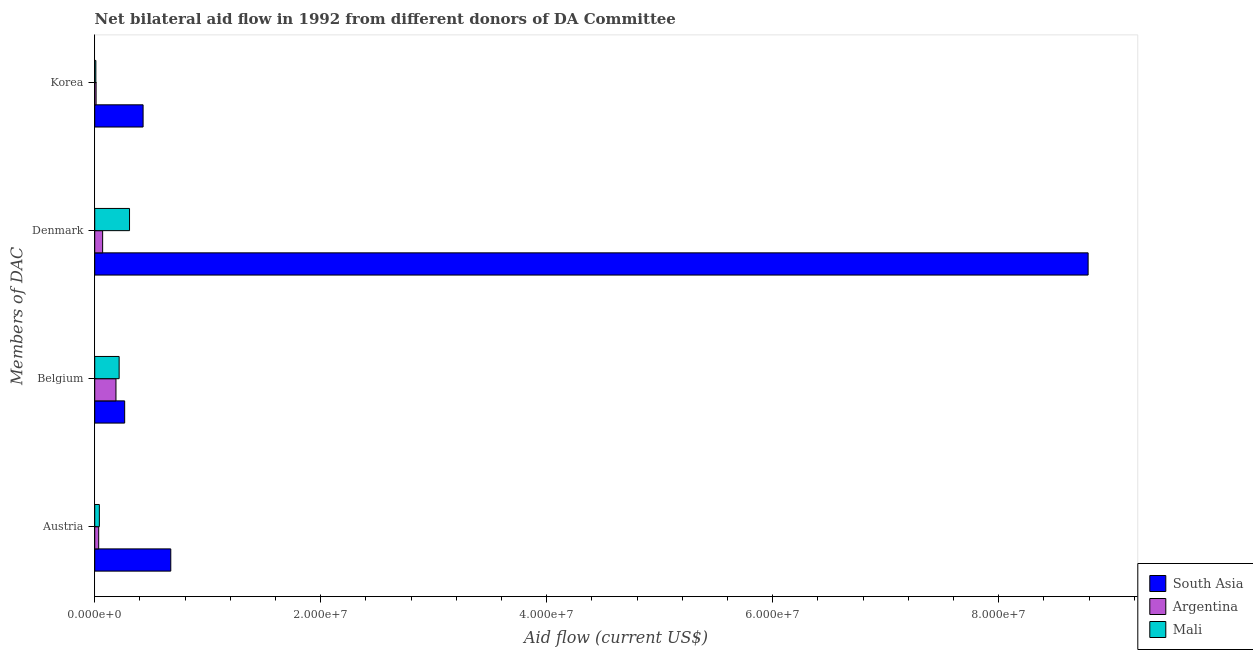How many different coloured bars are there?
Your answer should be compact. 3. Are the number of bars on each tick of the Y-axis equal?
Provide a succinct answer. Yes. How many bars are there on the 3rd tick from the bottom?
Your answer should be compact. 3. What is the amount of aid given by denmark in Argentina?
Your answer should be compact. 7.00e+05. Across all countries, what is the maximum amount of aid given by denmark?
Your response must be concise. 8.79e+07. Across all countries, what is the minimum amount of aid given by austria?
Ensure brevity in your answer.  3.50e+05. In which country was the amount of aid given by korea minimum?
Make the answer very short. Mali. What is the total amount of aid given by belgium in the graph?
Provide a succinct answer. 6.69e+06. What is the difference between the amount of aid given by austria in Argentina and that in South Asia?
Offer a very short reply. -6.38e+06. What is the difference between the amount of aid given by denmark in Mali and the amount of aid given by belgium in Argentina?
Provide a short and direct response. 1.20e+06. What is the average amount of aid given by korea per country?
Make the answer very short. 1.50e+06. What is the difference between the amount of aid given by korea and amount of aid given by denmark in Argentina?
Ensure brevity in your answer.  -5.80e+05. What is the ratio of the amount of aid given by belgium in Argentina to that in South Asia?
Make the answer very short. 0.71. Is the amount of aid given by korea in Mali less than that in Argentina?
Offer a very short reply. Yes. What is the difference between the highest and the second highest amount of aid given by belgium?
Provide a succinct answer. 4.90e+05. What is the difference between the highest and the lowest amount of aid given by austria?
Your answer should be very brief. 6.38e+06. Is the sum of the amount of aid given by austria in Mali and Argentina greater than the maximum amount of aid given by belgium across all countries?
Offer a terse response. No. Is it the case that in every country, the sum of the amount of aid given by korea and amount of aid given by austria is greater than the sum of amount of aid given by belgium and amount of aid given by denmark?
Your answer should be very brief. No. What does the 2nd bar from the top in Denmark represents?
Give a very brief answer. Argentina. What does the 1st bar from the bottom in Austria represents?
Give a very brief answer. South Asia. How many bars are there?
Offer a terse response. 12. Are all the bars in the graph horizontal?
Make the answer very short. Yes. How many countries are there in the graph?
Provide a short and direct response. 3. Does the graph contain any zero values?
Keep it short and to the point. No. How many legend labels are there?
Your answer should be compact. 3. How are the legend labels stacked?
Your response must be concise. Vertical. What is the title of the graph?
Your response must be concise. Net bilateral aid flow in 1992 from different donors of DA Committee. Does "Honduras" appear as one of the legend labels in the graph?
Provide a short and direct response. No. What is the label or title of the Y-axis?
Your answer should be compact. Members of DAC. What is the Aid flow (current US$) in South Asia in Austria?
Offer a terse response. 6.73e+06. What is the Aid flow (current US$) in Argentina in Austria?
Offer a very short reply. 3.50e+05. What is the Aid flow (current US$) in Mali in Austria?
Keep it short and to the point. 4.10e+05. What is the Aid flow (current US$) in South Asia in Belgium?
Offer a very short reply. 2.65e+06. What is the Aid flow (current US$) in Argentina in Belgium?
Offer a very short reply. 1.88e+06. What is the Aid flow (current US$) in Mali in Belgium?
Offer a terse response. 2.16e+06. What is the Aid flow (current US$) of South Asia in Denmark?
Keep it short and to the point. 8.79e+07. What is the Aid flow (current US$) in Mali in Denmark?
Your answer should be compact. 3.08e+06. What is the Aid flow (current US$) of South Asia in Korea?
Your response must be concise. 4.28e+06. What is the Aid flow (current US$) in Argentina in Korea?
Your response must be concise. 1.20e+05. Across all Members of DAC, what is the maximum Aid flow (current US$) in South Asia?
Keep it short and to the point. 8.79e+07. Across all Members of DAC, what is the maximum Aid flow (current US$) in Argentina?
Keep it short and to the point. 1.88e+06. Across all Members of DAC, what is the maximum Aid flow (current US$) in Mali?
Give a very brief answer. 3.08e+06. Across all Members of DAC, what is the minimum Aid flow (current US$) of South Asia?
Ensure brevity in your answer.  2.65e+06. Across all Members of DAC, what is the minimum Aid flow (current US$) of Argentina?
Offer a terse response. 1.20e+05. Across all Members of DAC, what is the minimum Aid flow (current US$) in Mali?
Provide a short and direct response. 1.00e+05. What is the total Aid flow (current US$) in South Asia in the graph?
Your answer should be compact. 1.02e+08. What is the total Aid flow (current US$) of Argentina in the graph?
Ensure brevity in your answer.  3.05e+06. What is the total Aid flow (current US$) in Mali in the graph?
Your response must be concise. 5.75e+06. What is the difference between the Aid flow (current US$) of South Asia in Austria and that in Belgium?
Keep it short and to the point. 4.08e+06. What is the difference between the Aid flow (current US$) of Argentina in Austria and that in Belgium?
Keep it short and to the point. -1.53e+06. What is the difference between the Aid flow (current US$) in Mali in Austria and that in Belgium?
Your response must be concise. -1.75e+06. What is the difference between the Aid flow (current US$) in South Asia in Austria and that in Denmark?
Make the answer very short. -8.12e+07. What is the difference between the Aid flow (current US$) of Argentina in Austria and that in Denmark?
Ensure brevity in your answer.  -3.50e+05. What is the difference between the Aid flow (current US$) of Mali in Austria and that in Denmark?
Make the answer very short. -2.67e+06. What is the difference between the Aid flow (current US$) in South Asia in Austria and that in Korea?
Offer a very short reply. 2.45e+06. What is the difference between the Aid flow (current US$) in Mali in Austria and that in Korea?
Offer a very short reply. 3.10e+05. What is the difference between the Aid flow (current US$) of South Asia in Belgium and that in Denmark?
Make the answer very short. -8.53e+07. What is the difference between the Aid flow (current US$) of Argentina in Belgium and that in Denmark?
Provide a short and direct response. 1.18e+06. What is the difference between the Aid flow (current US$) in Mali in Belgium and that in Denmark?
Give a very brief answer. -9.20e+05. What is the difference between the Aid flow (current US$) of South Asia in Belgium and that in Korea?
Ensure brevity in your answer.  -1.63e+06. What is the difference between the Aid flow (current US$) of Argentina in Belgium and that in Korea?
Your answer should be very brief. 1.76e+06. What is the difference between the Aid flow (current US$) in Mali in Belgium and that in Korea?
Ensure brevity in your answer.  2.06e+06. What is the difference between the Aid flow (current US$) of South Asia in Denmark and that in Korea?
Offer a terse response. 8.36e+07. What is the difference between the Aid flow (current US$) of Argentina in Denmark and that in Korea?
Provide a succinct answer. 5.80e+05. What is the difference between the Aid flow (current US$) of Mali in Denmark and that in Korea?
Offer a very short reply. 2.98e+06. What is the difference between the Aid flow (current US$) in South Asia in Austria and the Aid flow (current US$) in Argentina in Belgium?
Your answer should be very brief. 4.85e+06. What is the difference between the Aid flow (current US$) of South Asia in Austria and the Aid flow (current US$) of Mali in Belgium?
Offer a very short reply. 4.57e+06. What is the difference between the Aid flow (current US$) in Argentina in Austria and the Aid flow (current US$) in Mali in Belgium?
Provide a succinct answer. -1.81e+06. What is the difference between the Aid flow (current US$) of South Asia in Austria and the Aid flow (current US$) of Argentina in Denmark?
Keep it short and to the point. 6.03e+06. What is the difference between the Aid flow (current US$) in South Asia in Austria and the Aid flow (current US$) in Mali in Denmark?
Give a very brief answer. 3.65e+06. What is the difference between the Aid flow (current US$) in Argentina in Austria and the Aid flow (current US$) in Mali in Denmark?
Provide a succinct answer. -2.73e+06. What is the difference between the Aid flow (current US$) of South Asia in Austria and the Aid flow (current US$) of Argentina in Korea?
Offer a very short reply. 6.61e+06. What is the difference between the Aid flow (current US$) in South Asia in Austria and the Aid flow (current US$) in Mali in Korea?
Make the answer very short. 6.63e+06. What is the difference between the Aid flow (current US$) of Argentina in Austria and the Aid flow (current US$) of Mali in Korea?
Your answer should be very brief. 2.50e+05. What is the difference between the Aid flow (current US$) in South Asia in Belgium and the Aid flow (current US$) in Argentina in Denmark?
Your answer should be compact. 1.95e+06. What is the difference between the Aid flow (current US$) in South Asia in Belgium and the Aid flow (current US$) in Mali in Denmark?
Your answer should be very brief. -4.30e+05. What is the difference between the Aid flow (current US$) of Argentina in Belgium and the Aid flow (current US$) of Mali in Denmark?
Make the answer very short. -1.20e+06. What is the difference between the Aid flow (current US$) of South Asia in Belgium and the Aid flow (current US$) of Argentina in Korea?
Keep it short and to the point. 2.53e+06. What is the difference between the Aid flow (current US$) of South Asia in Belgium and the Aid flow (current US$) of Mali in Korea?
Offer a terse response. 2.55e+06. What is the difference between the Aid flow (current US$) in Argentina in Belgium and the Aid flow (current US$) in Mali in Korea?
Give a very brief answer. 1.78e+06. What is the difference between the Aid flow (current US$) of South Asia in Denmark and the Aid flow (current US$) of Argentina in Korea?
Offer a terse response. 8.78e+07. What is the difference between the Aid flow (current US$) of South Asia in Denmark and the Aid flow (current US$) of Mali in Korea?
Ensure brevity in your answer.  8.78e+07. What is the difference between the Aid flow (current US$) of Argentina in Denmark and the Aid flow (current US$) of Mali in Korea?
Provide a succinct answer. 6.00e+05. What is the average Aid flow (current US$) in South Asia per Members of DAC?
Provide a short and direct response. 2.54e+07. What is the average Aid flow (current US$) in Argentina per Members of DAC?
Keep it short and to the point. 7.62e+05. What is the average Aid flow (current US$) of Mali per Members of DAC?
Make the answer very short. 1.44e+06. What is the difference between the Aid flow (current US$) in South Asia and Aid flow (current US$) in Argentina in Austria?
Offer a very short reply. 6.38e+06. What is the difference between the Aid flow (current US$) of South Asia and Aid flow (current US$) of Mali in Austria?
Give a very brief answer. 6.32e+06. What is the difference between the Aid flow (current US$) of South Asia and Aid flow (current US$) of Argentina in Belgium?
Ensure brevity in your answer.  7.70e+05. What is the difference between the Aid flow (current US$) of South Asia and Aid flow (current US$) of Mali in Belgium?
Make the answer very short. 4.90e+05. What is the difference between the Aid flow (current US$) in Argentina and Aid flow (current US$) in Mali in Belgium?
Offer a very short reply. -2.80e+05. What is the difference between the Aid flow (current US$) in South Asia and Aid flow (current US$) in Argentina in Denmark?
Keep it short and to the point. 8.72e+07. What is the difference between the Aid flow (current US$) in South Asia and Aid flow (current US$) in Mali in Denmark?
Offer a terse response. 8.48e+07. What is the difference between the Aid flow (current US$) in Argentina and Aid flow (current US$) in Mali in Denmark?
Your answer should be compact. -2.38e+06. What is the difference between the Aid flow (current US$) in South Asia and Aid flow (current US$) in Argentina in Korea?
Your answer should be compact. 4.16e+06. What is the difference between the Aid flow (current US$) in South Asia and Aid flow (current US$) in Mali in Korea?
Make the answer very short. 4.18e+06. What is the difference between the Aid flow (current US$) of Argentina and Aid flow (current US$) of Mali in Korea?
Provide a short and direct response. 2.00e+04. What is the ratio of the Aid flow (current US$) of South Asia in Austria to that in Belgium?
Give a very brief answer. 2.54. What is the ratio of the Aid flow (current US$) of Argentina in Austria to that in Belgium?
Offer a very short reply. 0.19. What is the ratio of the Aid flow (current US$) in Mali in Austria to that in Belgium?
Offer a terse response. 0.19. What is the ratio of the Aid flow (current US$) of South Asia in Austria to that in Denmark?
Your answer should be very brief. 0.08. What is the ratio of the Aid flow (current US$) of Argentina in Austria to that in Denmark?
Give a very brief answer. 0.5. What is the ratio of the Aid flow (current US$) in Mali in Austria to that in Denmark?
Your answer should be compact. 0.13. What is the ratio of the Aid flow (current US$) of South Asia in Austria to that in Korea?
Offer a terse response. 1.57. What is the ratio of the Aid flow (current US$) of Argentina in Austria to that in Korea?
Your answer should be very brief. 2.92. What is the ratio of the Aid flow (current US$) in Mali in Austria to that in Korea?
Your answer should be very brief. 4.1. What is the ratio of the Aid flow (current US$) in South Asia in Belgium to that in Denmark?
Give a very brief answer. 0.03. What is the ratio of the Aid flow (current US$) in Argentina in Belgium to that in Denmark?
Offer a very short reply. 2.69. What is the ratio of the Aid flow (current US$) in Mali in Belgium to that in Denmark?
Make the answer very short. 0.7. What is the ratio of the Aid flow (current US$) in South Asia in Belgium to that in Korea?
Provide a short and direct response. 0.62. What is the ratio of the Aid flow (current US$) of Argentina in Belgium to that in Korea?
Keep it short and to the point. 15.67. What is the ratio of the Aid flow (current US$) of Mali in Belgium to that in Korea?
Keep it short and to the point. 21.6. What is the ratio of the Aid flow (current US$) in South Asia in Denmark to that in Korea?
Provide a short and direct response. 20.54. What is the ratio of the Aid flow (current US$) of Argentina in Denmark to that in Korea?
Offer a terse response. 5.83. What is the ratio of the Aid flow (current US$) of Mali in Denmark to that in Korea?
Provide a short and direct response. 30.8. What is the difference between the highest and the second highest Aid flow (current US$) of South Asia?
Give a very brief answer. 8.12e+07. What is the difference between the highest and the second highest Aid flow (current US$) of Argentina?
Your response must be concise. 1.18e+06. What is the difference between the highest and the second highest Aid flow (current US$) in Mali?
Offer a terse response. 9.20e+05. What is the difference between the highest and the lowest Aid flow (current US$) of South Asia?
Your answer should be very brief. 8.53e+07. What is the difference between the highest and the lowest Aid flow (current US$) of Argentina?
Ensure brevity in your answer.  1.76e+06. What is the difference between the highest and the lowest Aid flow (current US$) in Mali?
Your answer should be compact. 2.98e+06. 